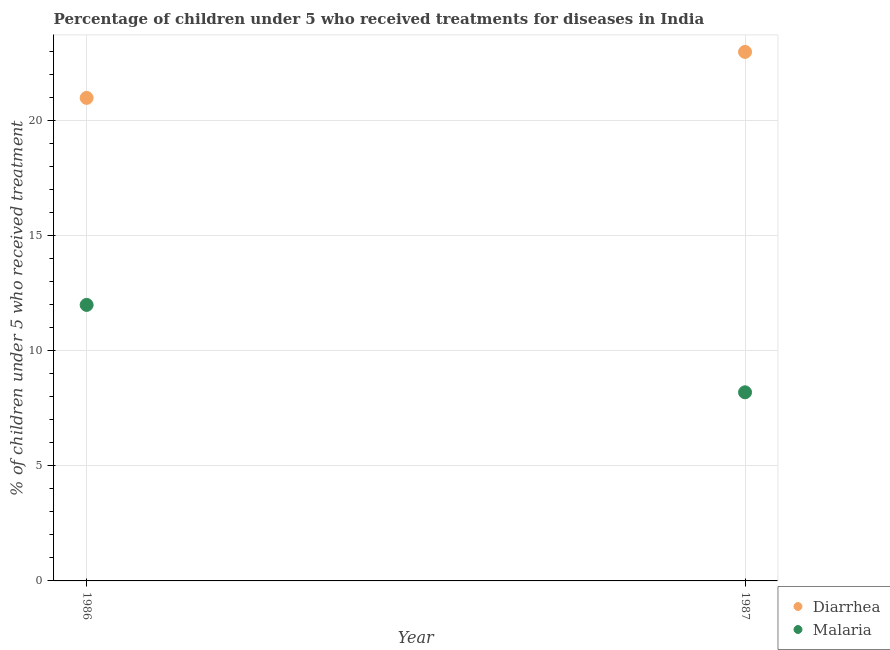Is the number of dotlines equal to the number of legend labels?
Make the answer very short. Yes. What is the percentage of children who received treatment for malaria in 1987?
Give a very brief answer. 8.2. Across all years, what is the maximum percentage of children who received treatment for diarrhoea?
Offer a terse response. 23. Across all years, what is the minimum percentage of children who received treatment for diarrhoea?
Offer a very short reply. 21. What is the total percentage of children who received treatment for malaria in the graph?
Your response must be concise. 20.2. What is the difference between the percentage of children who received treatment for malaria in 1986 and that in 1987?
Provide a succinct answer. 3.8. In the year 1987, what is the difference between the percentage of children who received treatment for diarrhoea and percentage of children who received treatment for malaria?
Your response must be concise. 14.8. What is the ratio of the percentage of children who received treatment for malaria in 1986 to that in 1987?
Ensure brevity in your answer.  1.46. How many dotlines are there?
Provide a succinct answer. 2. How many years are there in the graph?
Provide a succinct answer. 2. What is the difference between two consecutive major ticks on the Y-axis?
Your response must be concise. 5. Does the graph contain grids?
Your answer should be compact. Yes. Where does the legend appear in the graph?
Make the answer very short. Bottom right. How many legend labels are there?
Give a very brief answer. 2. How are the legend labels stacked?
Ensure brevity in your answer.  Vertical. What is the title of the graph?
Provide a succinct answer. Percentage of children under 5 who received treatments for diseases in India. Does "Passenger Transport Items" appear as one of the legend labels in the graph?
Provide a short and direct response. No. What is the label or title of the Y-axis?
Give a very brief answer. % of children under 5 who received treatment. What is the % of children under 5 who received treatment in Diarrhea in 1986?
Give a very brief answer. 21. What is the % of children under 5 who received treatment in Malaria in 1987?
Keep it short and to the point. 8.2. Across all years, what is the maximum % of children under 5 who received treatment in Diarrhea?
Make the answer very short. 23. Across all years, what is the minimum % of children under 5 who received treatment in Diarrhea?
Your answer should be compact. 21. What is the total % of children under 5 who received treatment of Diarrhea in the graph?
Keep it short and to the point. 44. What is the total % of children under 5 who received treatment in Malaria in the graph?
Your response must be concise. 20.2. What is the difference between the % of children under 5 who received treatment in Diarrhea in 1986 and that in 1987?
Give a very brief answer. -2. What is the difference between the % of children under 5 who received treatment in Malaria in 1986 and that in 1987?
Make the answer very short. 3.8. In the year 1987, what is the difference between the % of children under 5 who received treatment of Diarrhea and % of children under 5 who received treatment of Malaria?
Provide a short and direct response. 14.8. What is the ratio of the % of children under 5 who received treatment in Diarrhea in 1986 to that in 1987?
Make the answer very short. 0.91. What is the ratio of the % of children under 5 who received treatment in Malaria in 1986 to that in 1987?
Ensure brevity in your answer.  1.46. What is the difference between the highest and the second highest % of children under 5 who received treatment of Diarrhea?
Make the answer very short. 2. What is the difference between the highest and the second highest % of children under 5 who received treatment in Malaria?
Offer a very short reply. 3.8. What is the difference between the highest and the lowest % of children under 5 who received treatment in Diarrhea?
Keep it short and to the point. 2. What is the difference between the highest and the lowest % of children under 5 who received treatment in Malaria?
Your response must be concise. 3.8. 